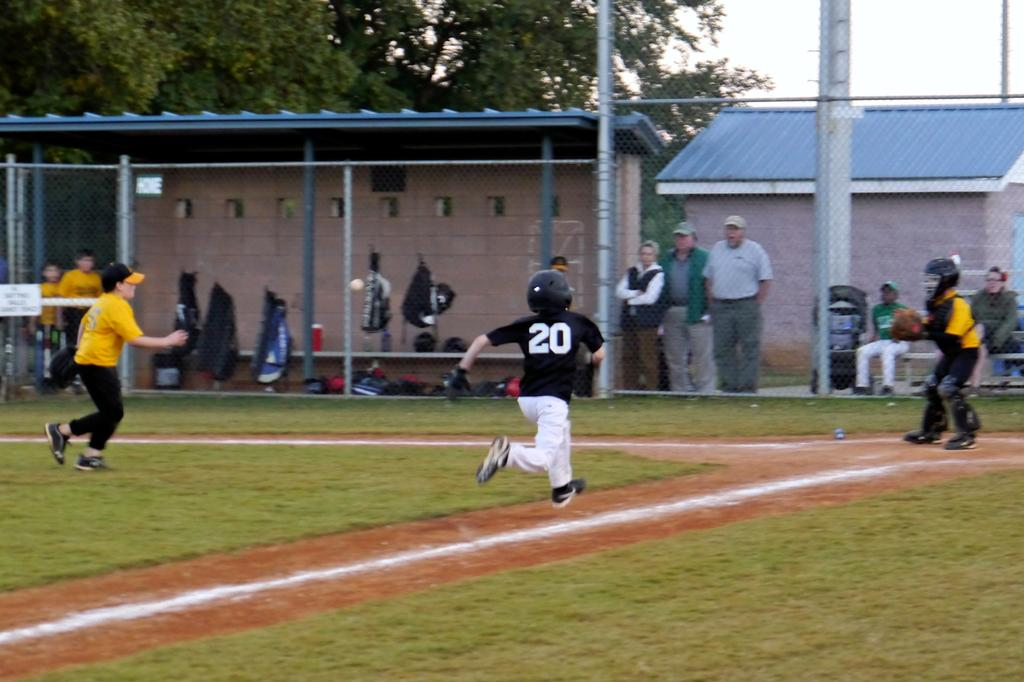<image>
Write a terse but informative summary of the picture. A children's softball game is underway and the player running for home base has a 20 on his shirt. 